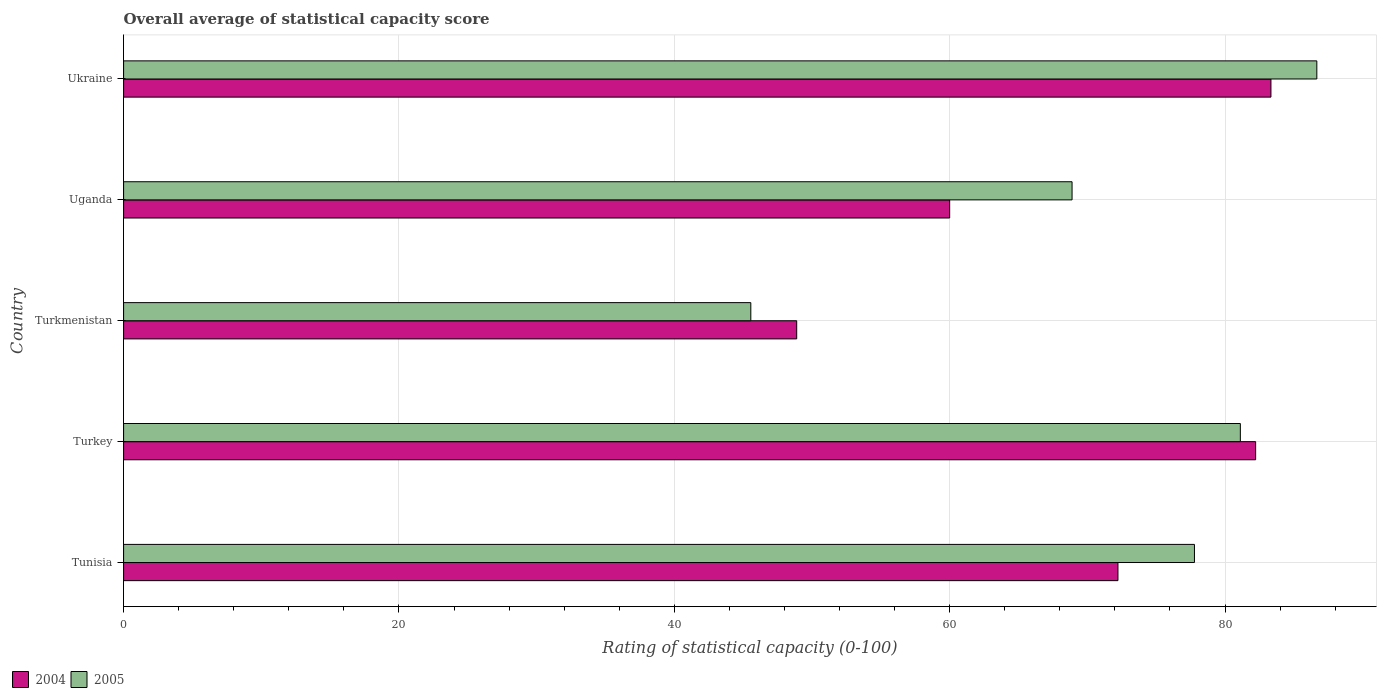How many different coloured bars are there?
Keep it short and to the point. 2. How many groups of bars are there?
Your answer should be compact. 5. Are the number of bars per tick equal to the number of legend labels?
Your response must be concise. Yes. What is the label of the 2nd group of bars from the top?
Ensure brevity in your answer.  Uganda. In how many cases, is the number of bars for a given country not equal to the number of legend labels?
Your answer should be compact. 0. What is the rating of statistical capacity in 2005 in Uganda?
Provide a succinct answer. 68.89. Across all countries, what is the maximum rating of statistical capacity in 2005?
Provide a short and direct response. 86.67. Across all countries, what is the minimum rating of statistical capacity in 2004?
Keep it short and to the point. 48.89. In which country was the rating of statistical capacity in 2004 maximum?
Your answer should be very brief. Ukraine. In which country was the rating of statistical capacity in 2005 minimum?
Offer a very short reply. Turkmenistan. What is the total rating of statistical capacity in 2004 in the graph?
Provide a succinct answer. 346.67. What is the difference between the rating of statistical capacity in 2005 in Tunisia and that in Uganda?
Make the answer very short. 8.89. What is the difference between the rating of statistical capacity in 2005 in Turkey and the rating of statistical capacity in 2004 in Tunisia?
Give a very brief answer. 8.89. What is the average rating of statistical capacity in 2005 per country?
Offer a very short reply. 72. What is the difference between the rating of statistical capacity in 2004 and rating of statistical capacity in 2005 in Turkmenistan?
Your answer should be compact. 3.33. In how many countries, is the rating of statistical capacity in 2004 greater than 48 ?
Give a very brief answer. 5. What is the ratio of the rating of statistical capacity in 2004 in Turkey to that in Uganda?
Your answer should be compact. 1.37. Is the rating of statistical capacity in 2004 in Uganda less than that in Ukraine?
Offer a terse response. Yes. Is the difference between the rating of statistical capacity in 2004 in Turkey and Turkmenistan greater than the difference between the rating of statistical capacity in 2005 in Turkey and Turkmenistan?
Ensure brevity in your answer.  No. What is the difference between the highest and the second highest rating of statistical capacity in 2005?
Your answer should be compact. 5.56. What is the difference between the highest and the lowest rating of statistical capacity in 2005?
Give a very brief answer. 41.11. Is the sum of the rating of statistical capacity in 2004 in Turkey and Uganda greater than the maximum rating of statistical capacity in 2005 across all countries?
Provide a short and direct response. Yes. How many bars are there?
Keep it short and to the point. 10. What is the difference between two consecutive major ticks on the X-axis?
Provide a short and direct response. 20. Does the graph contain grids?
Offer a terse response. Yes. Where does the legend appear in the graph?
Keep it short and to the point. Bottom left. How many legend labels are there?
Your answer should be very brief. 2. What is the title of the graph?
Your response must be concise. Overall average of statistical capacity score. What is the label or title of the X-axis?
Make the answer very short. Rating of statistical capacity (0-100). What is the Rating of statistical capacity (0-100) of 2004 in Tunisia?
Your response must be concise. 72.22. What is the Rating of statistical capacity (0-100) of 2005 in Tunisia?
Make the answer very short. 77.78. What is the Rating of statistical capacity (0-100) of 2004 in Turkey?
Offer a very short reply. 82.22. What is the Rating of statistical capacity (0-100) of 2005 in Turkey?
Provide a short and direct response. 81.11. What is the Rating of statistical capacity (0-100) of 2004 in Turkmenistan?
Ensure brevity in your answer.  48.89. What is the Rating of statistical capacity (0-100) in 2005 in Turkmenistan?
Keep it short and to the point. 45.56. What is the Rating of statistical capacity (0-100) in 2005 in Uganda?
Ensure brevity in your answer.  68.89. What is the Rating of statistical capacity (0-100) of 2004 in Ukraine?
Provide a short and direct response. 83.33. What is the Rating of statistical capacity (0-100) in 2005 in Ukraine?
Ensure brevity in your answer.  86.67. Across all countries, what is the maximum Rating of statistical capacity (0-100) of 2004?
Offer a very short reply. 83.33. Across all countries, what is the maximum Rating of statistical capacity (0-100) of 2005?
Your answer should be compact. 86.67. Across all countries, what is the minimum Rating of statistical capacity (0-100) of 2004?
Provide a short and direct response. 48.89. Across all countries, what is the minimum Rating of statistical capacity (0-100) of 2005?
Ensure brevity in your answer.  45.56. What is the total Rating of statistical capacity (0-100) in 2004 in the graph?
Ensure brevity in your answer.  346.67. What is the total Rating of statistical capacity (0-100) in 2005 in the graph?
Offer a very short reply. 360. What is the difference between the Rating of statistical capacity (0-100) of 2004 in Tunisia and that in Turkey?
Provide a short and direct response. -10. What is the difference between the Rating of statistical capacity (0-100) of 2004 in Tunisia and that in Turkmenistan?
Ensure brevity in your answer.  23.33. What is the difference between the Rating of statistical capacity (0-100) of 2005 in Tunisia and that in Turkmenistan?
Your response must be concise. 32.22. What is the difference between the Rating of statistical capacity (0-100) in 2004 in Tunisia and that in Uganda?
Keep it short and to the point. 12.22. What is the difference between the Rating of statistical capacity (0-100) of 2005 in Tunisia and that in Uganda?
Provide a short and direct response. 8.89. What is the difference between the Rating of statistical capacity (0-100) of 2004 in Tunisia and that in Ukraine?
Your answer should be very brief. -11.11. What is the difference between the Rating of statistical capacity (0-100) in 2005 in Tunisia and that in Ukraine?
Provide a succinct answer. -8.89. What is the difference between the Rating of statistical capacity (0-100) in 2004 in Turkey and that in Turkmenistan?
Give a very brief answer. 33.33. What is the difference between the Rating of statistical capacity (0-100) of 2005 in Turkey and that in Turkmenistan?
Provide a short and direct response. 35.56. What is the difference between the Rating of statistical capacity (0-100) in 2004 in Turkey and that in Uganda?
Provide a succinct answer. 22.22. What is the difference between the Rating of statistical capacity (0-100) in 2005 in Turkey and that in Uganda?
Give a very brief answer. 12.22. What is the difference between the Rating of statistical capacity (0-100) of 2004 in Turkey and that in Ukraine?
Provide a short and direct response. -1.11. What is the difference between the Rating of statistical capacity (0-100) of 2005 in Turkey and that in Ukraine?
Provide a short and direct response. -5.56. What is the difference between the Rating of statistical capacity (0-100) in 2004 in Turkmenistan and that in Uganda?
Ensure brevity in your answer.  -11.11. What is the difference between the Rating of statistical capacity (0-100) of 2005 in Turkmenistan and that in Uganda?
Make the answer very short. -23.33. What is the difference between the Rating of statistical capacity (0-100) of 2004 in Turkmenistan and that in Ukraine?
Ensure brevity in your answer.  -34.44. What is the difference between the Rating of statistical capacity (0-100) in 2005 in Turkmenistan and that in Ukraine?
Keep it short and to the point. -41.11. What is the difference between the Rating of statistical capacity (0-100) in 2004 in Uganda and that in Ukraine?
Ensure brevity in your answer.  -23.33. What is the difference between the Rating of statistical capacity (0-100) in 2005 in Uganda and that in Ukraine?
Make the answer very short. -17.78. What is the difference between the Rating of statistical capacity (0-100) of 2004 in Tunisia and the Rating of statistical capacity (0-100) of 2005 in Turkey?
Your answer should be very brief. -8.89. What is the difference between the Rating of statistical capacity (0-100) of 2004 in Tunisia and the Rating of statistical capacity (0-100) of 2005 in Turkmenistan?
Your answer should be very brief. 26.67. What is the difference between the Rating of statistical capacity (0-100) of 2004 in Tunisia and the Rating of statistical capacity (0-100) of 2005 in Ukraine?
Your answer should be very brief. -14.44. What is the difference between the Rating of statistical capacity (0-100) in 2004 in Turkey and the Rating of statistical capacity (0-100) in 2005 in Turkmenistan?
Keep it short and to the point. 36.67. What is the difference between the Rating of statistical capacity (0-100) of 2004 in Turkey and the Rating of statistical capacity (0-100) of 2005 in Uganda?
Your response must be concise. 13.33. What is the difference between the Rating of statistical capacity (0-100) in 2004 in Turkey and the Rating of statistical capacity (0-100) in 2005 in Ukraine?
Provide a succinct answer. -4.44. What is the difference between the Rating of statistical capacity (0-100) of 2004 in Turkmenistan and the Rating of statistical capacity (0-100) of 2005 in Uganda?
Keep it short and to the point. -20. What is the difference between the Rating of statistical capacity (0-100) of 2004 in Turkmenistan and the Rating of statistical capacity (0-100) of 2005 in Ukraine?
Offer a terse response. -37.78. What is the difference between the Rating of statistical capacity (0-100) in 2004 in Uganda and the Rating of statistical capacity (0-100) in 2005 in Ukraine?
Keep it short and to the point. -26.67. What is the average Rating of statistical capacity (0-100) in 2004 per country?
Offer a very short reply. 69.33. What is the difference between the Rating of statistical capacity (0-100) of 2004 and Rating of statistical capacity (0-100) of 2005 in Tunisia?
Your answer should be very brief. -5.56. What is the difference between the Rating of statistical capacity (0-100) of 2004 and Rating of statistical capacity (0-100) of 2005 in Turkey?
Offer a terse response. 1.11. What is the difference between the Rating of statistical capacity (0-100) of 2004 and Rating of statistical capacity (0-100) of 2005 in Uganda?
Offer a very short reply. -8.89. What is the difference between the Rating of statistical capacity (0-100) in 2004 and Rating of statistical capacity (0-100) in 2005 in Ukraine?
Your answer should be very brief. -3.33. What is the ratio of the Rating of statistical capacity (0-100) of 2004 in Tunisia to that in Turkey?
Your answer should be compact. 0.88. What is the ratio of the Rating of statistical capacity (0-100) of 2005 in Tunisia to that in Turkey?
Your answer should be very brief. 0.96. What is the ratio of the Rating of statistical capacity (0-100) of 2004 in Tunisia to that in Turkmenistan?
Make the answer very short. 1.48. What is the ratio of the Rating of statistical capacity (0-100) of 2005 in Tunisia to that in Turkmenistan?
Give a very brief answer. 1.71. What is the ratio of the Rating of statistical capacity (0-100) of 2004 in Tunisia to that in Uganda?
Offer a terse response. 1.2. What is the ratio of the Rating of statistical capacity (0-100) of 2005 in Tunisia to that in Uganda?
Give a very brief answer. 1.13. What is the ratio of the Rating of statistical capacity (0-100) in 2004 in Tunisia to that in Ukraine?
Offer a very short reply. 0.87. What is the ratio of the Rating of statistical capacity (0-100) of 2005 in Tunisia to that in Ukraine?
Offer a terse response. 0.9. What is the ratio of the Rating of statistical capacity (0-100) of 2004 in Turkey to that in Turkmenistan?
Provide a succinct answer. 1.68. What is the ratio of the Rating of statistical capacity (0-100) of 2005 in Turkey to that in Turkmenistan?
Make the answer very short. 1.78. What is the ratio of the Rating of statistical capacity (0-100) of 2004 in Turkey to that in Uganda?
Keep it short and to the point. 1.37. What is the ratio of the Rating of statistical capacity (0-100) in 2005 in Turkey to that in Uganda?
Your answer should be compact. 1.18. What is the ratio of the Rating of statistical capacity (0-100) of 2004 in Turkey to that in Ukraine?
Your answer should be compact. 0.99. What is the ratio of the Rating of statistical capacity (0-100) of 2005 in Turkey to that in Ukraine?
Provide a succinct answer. 0.94. What is the ratio of the Rating of statistical capacity (0-100) of 2004 in Turkmenistan to that in Uganda?
Offer a terse response. 0.81. What is the ratio of the Rating of statistical capacity (0-100) in 2005 in Turkmenistan to that in Uganda?
Offer a terse response. 0.66. What is the ratio of the Rating of statistical capacity (0-100) in 2004 in Turkmenistan to that in Ukraine?
Your answer should be very brief. 0.59. What is the ratio of the Rating of statistical capacity (0-100) of 2005 in Turkmenistan to that in Ukraine?
Your response must be concise. 0.53. What is the ratio of the Rating of statistical capacity (0-100) of 2004 in Uganda to that in Ukraine?
Ensure brevity in your answer.  0.72. What is the ratio of the Rating of statistical capacity (0-100) in 2005 in Uganda to that in Ukraine?
Offer a terse response. 0.79. What is the difference between the highest and the second highest Rating of statistical capacity (0-100) of 2005?
Make the answer very short. 5.56. What is the difference between the highest and the lowest Rating of statistical capacity (0-100) of 2004?
Offer a terse response. 34.44. What is the difference between the highest and the lowest Rating of statistical capacity (0-100) in 2005?
Provide a succinct answer. 41.11. 